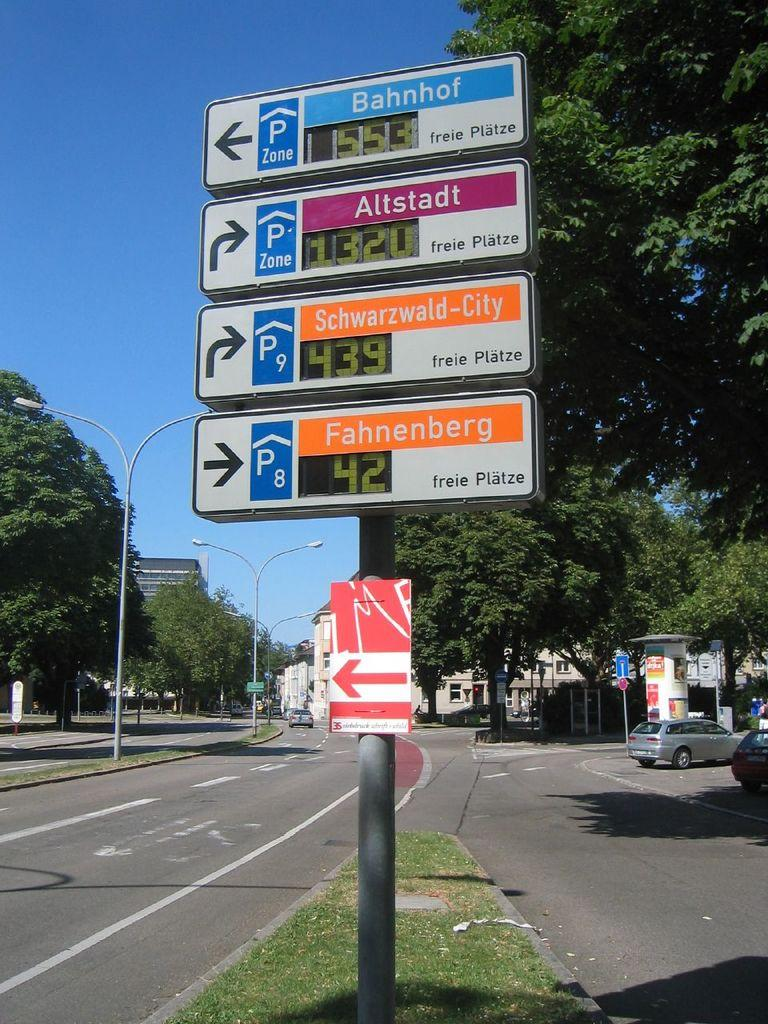<image>
Offer a succinct explanation of the picture presented. Signs on the median of a road include a sign that says Bahnhof. 